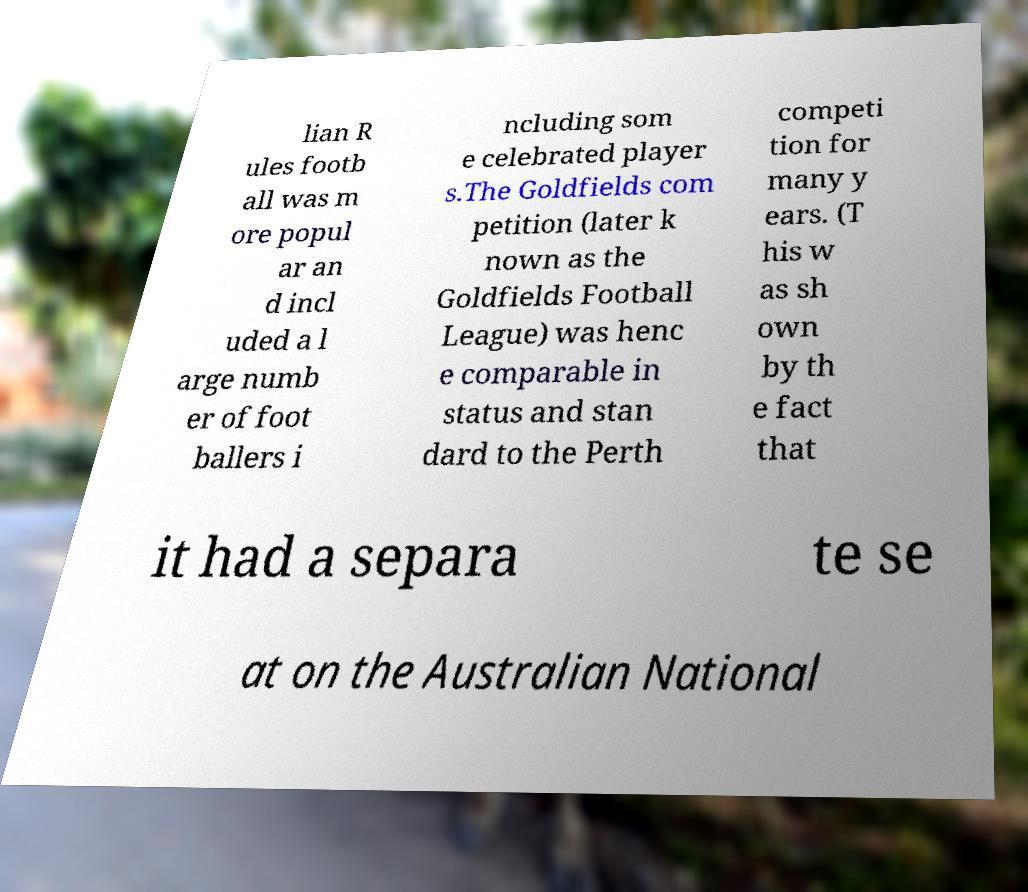There's text embedded in this image that I need extracted. Can you transcribe it verbatim? lian R ules footb all was m ore popul ar an d incl uded a l arge numb er of foot ballers i ncluding som e celebrated player s.The Goldfields com petition (later k nown as the Goldfields Football League) was henc e comparable in status and stan dard to the Perth competi tion for many y ears. (T his w as sh own by th e fact that it had a separa te se at on the Australian National 